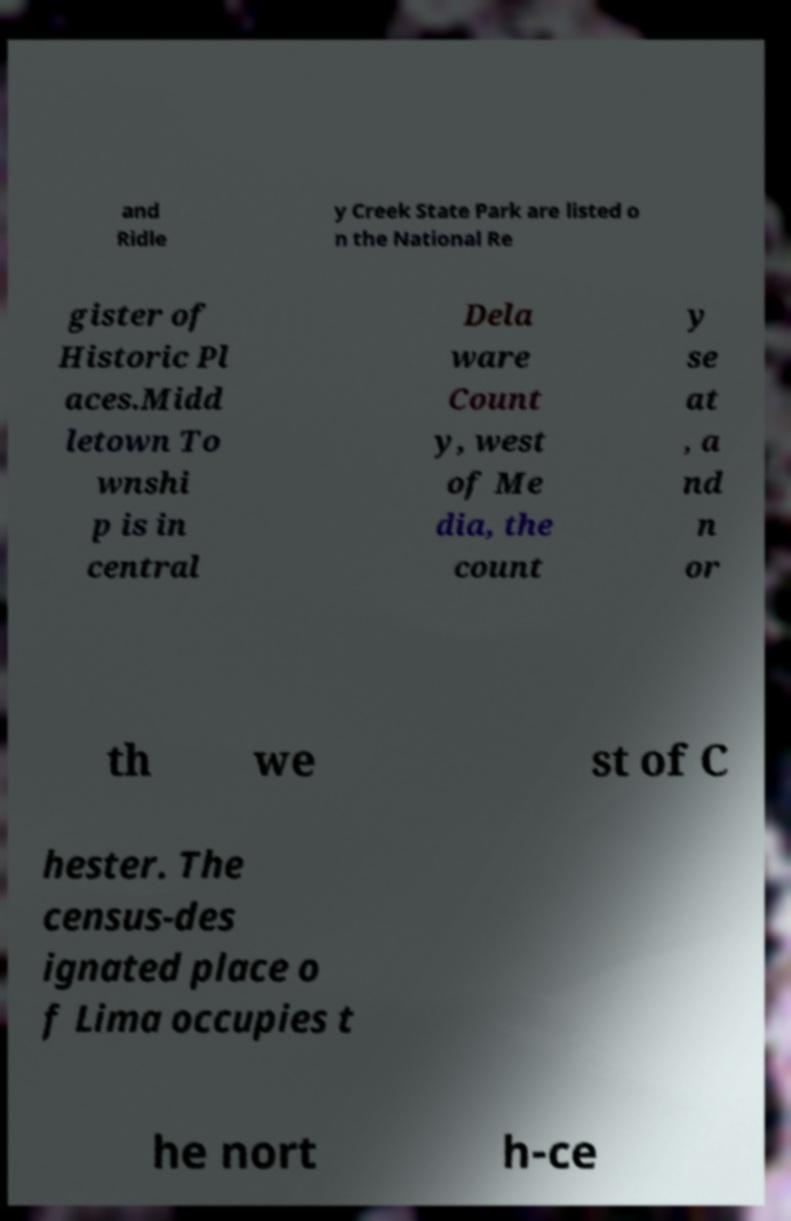There's text embedded in this image that I need extracted. Can you transcribe it verbatim? and Ridle y Creek State Park are listed o n the National Re gister of Historic Pl aces.Midd letown To wnshi p is in central Dela ware Count y, west of Me dia, the count y se at , a nd n or th we st of C hester. The census-des ignated place o f Lima occupies t he nort h-ce 